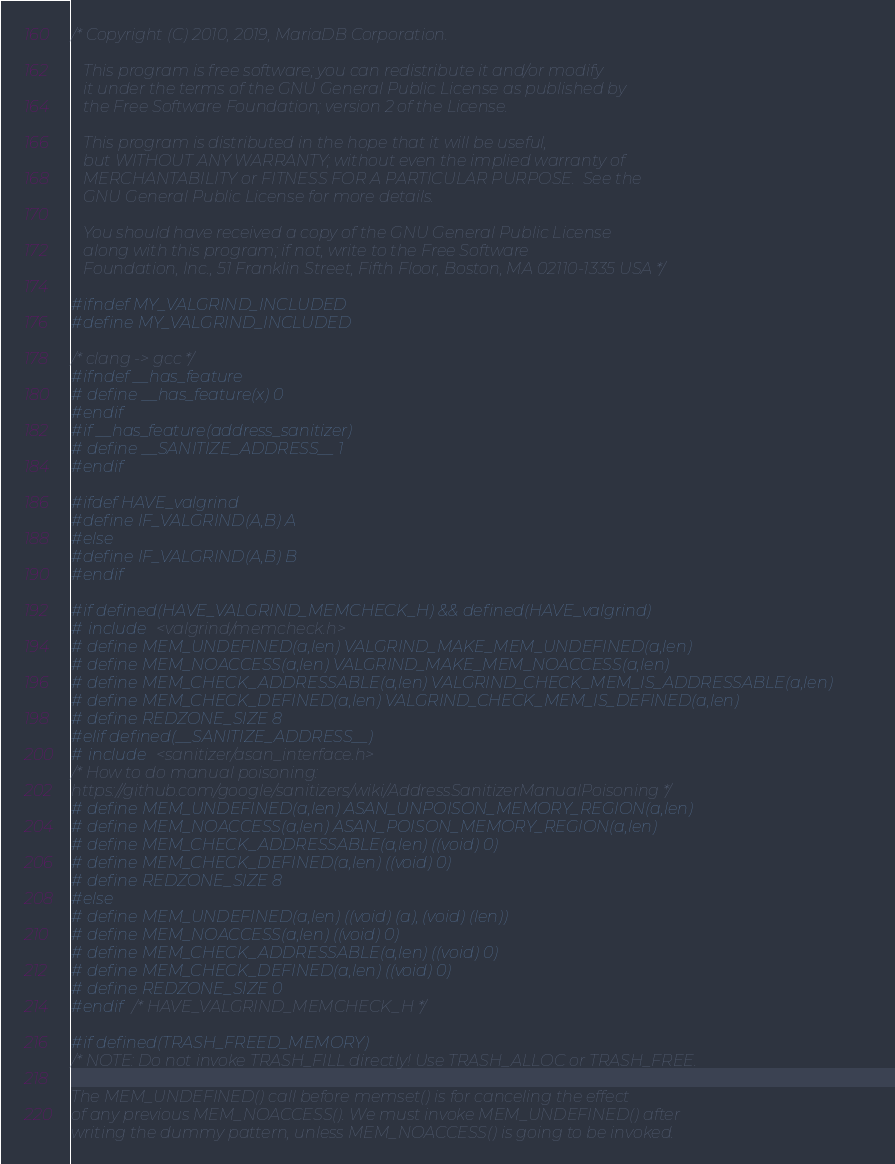<code> <loc_0><loc_0><loc_500><loc_500><_C_>/* Copyright (C) 2010, 2019, MariaDB Corporation.

   This program is free software; you can redistribute it and/or modify
   it under the terms of the GNU General Public License as published by
   the Free Software Foundation; version 2 of the License.

   This program is distributed in the hope that it will be useful,
   but WITHOUT ANY WARRANTY; without even the implied warranty of
   MERCHANTABILITY or FITNESS FOR A PARTICULAR PURPOSE.  See the
   GNU General Public License for more details.

   You should have received a copy of the GNU General Public License
   along with this program; if not, write to the Free Software
   Foundation, Inc., 51 Franklin Street, Fifth Floor, Boston, MA 02110-1335 USA */

#ifndef MY_VALGRIND_INCLUDED
#define MY_VALGRIND_INCLUDED

/* clang -> gcc */
#ifndef __has_feature
# define __has_feature(x) 0
#endif
#if __has_feature(address_sanitizer)
# define __SANITIZE_ADDRESS__ 1
#endif

#ifdef HAVE_valgrind
#define IF_VALGRIND(A,B) A
#else
#define IF_VALGRIND(A,B) B
#endif

#if defined(HAVE_VALGRIND_MEMCHECK_H) && defined(HAVE_valgrind)
# include <valgrind/memcheck.h>
# define MEM_UNDEFINED(a,len) VALGRIND_MAKE_MEM_UNDEFINED(a,len)
# define MEM_NOACCESS(a,len) VALGRIND_MAKE_MEM_NOACCESS(a,len)
# define MEM_CHECK_ADDRESSABLE(a,len) VALGRIND_CHECK_MEM_IS_ADDRESSABLE(a,len)
# define MEM_CHECK_DEFINED(a,len) VALGRIND_CHECK_MEM_IS_DEFINED(a,len)
# define REDZONE_SIZE 8
#elif defined(__SANITIZE_ADDRESS__)
# include <sanitizer/asan_interface.h>
/* How to do manual poisoning:
https://github.com/google/sanitizers/wiki/AddressSanitizerManualPoisoning */
# define MEM_UNDEFINED(a,len) ASAN_UNPOISON_MEMORY_REGION(a,len)
# define MEM_NOACCESS(a,len) ASAN_POISON_MEMORY_REGION(a,len)
# define MEM_CHECK_ADDRESSABLE(a,len) ((void) 0)
# define MEM_CHECK_DEFINED(a,len) ((void) 0)
# define REDZONE_SIZE 8
#else
# define MEM_UNDEFINED(a,len) ((void) (a), (void) (len))
# define MEM_NOACCESS(a,len) ((void) 0)
# define MEM_CHECK_ADDRESSABLE(a,len) ((void) 0)
# define MEM_CHECK_DEFINED(a,len) ((void) 0)
# define REDZONE_SIZE 0
#endif /* HAVE_VALGRIND_MEMCHECK_H */

#if defined(TRASH_FREED_MEMORY)
/* NOTE: Do not invoke TRASH_FILL directly! Use TRASH_ALLOC or TRASH_FREE.

The MEM_UNDEFINED() call before memset() is for canceling the effect
of any previous MEM_NOACCESS(). We must invoke MEM_UNDEFINED() after
writing the dummy pattern, unless MEM_NOACCESS() is going to be invoked.</code> 